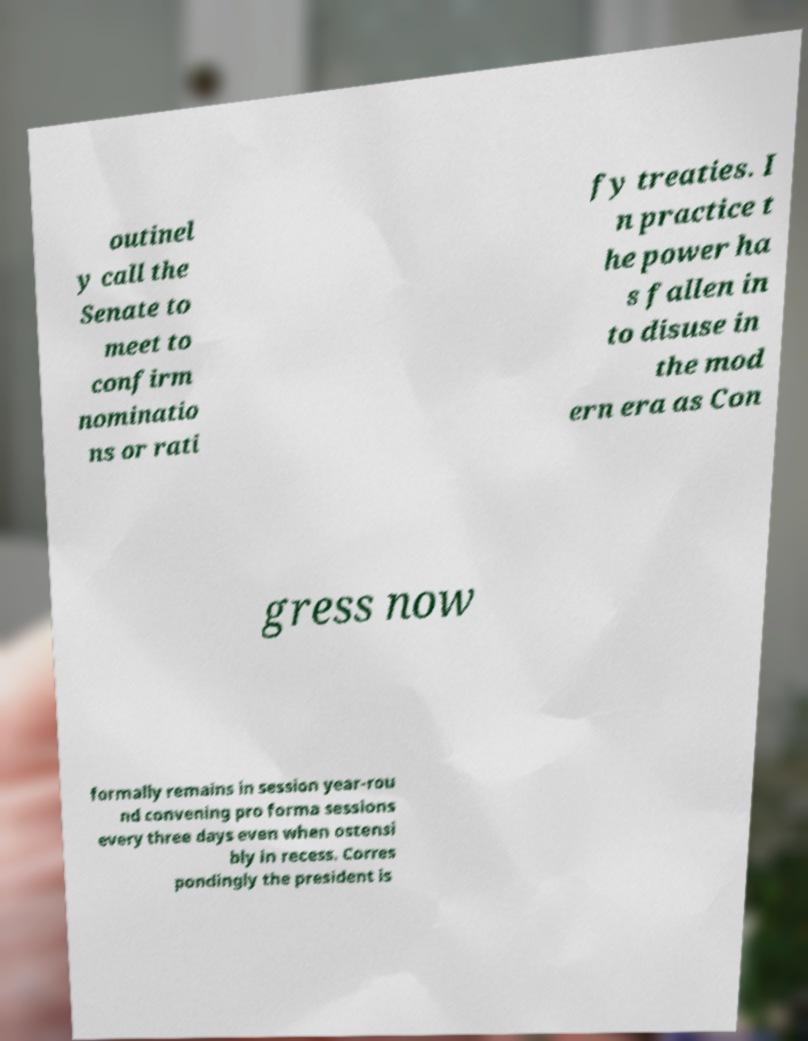Can you read and provide the text displayed in the image?This photo seems to have some interesting text. Can you extract and type it out for me? outinel y call the Senate to meet to confirm nominatio ns or rati fy treaties. I n practice t he power ha s fallen in to disuse in the mod ern era as Con gress now formally remains in session year-rou nd convening pro forma sessions every three days even when ostensi bly in recess. Corres pondingly the president is 